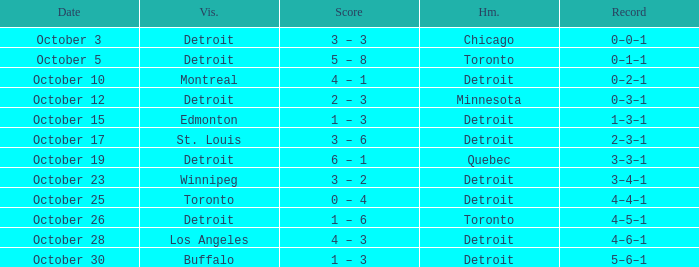Name the home with toronto visiting Detroit. 